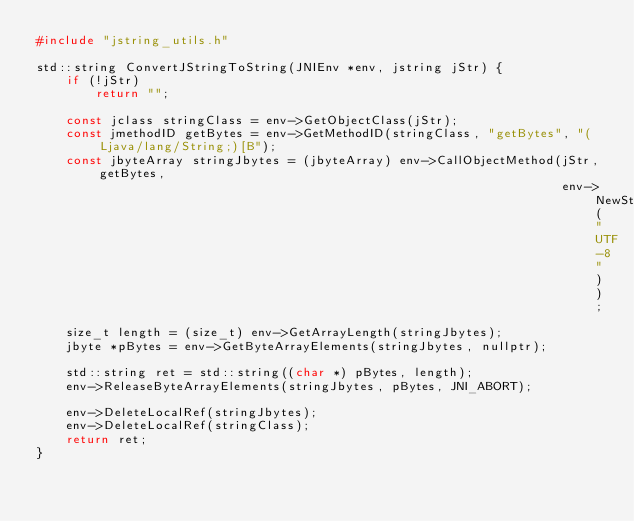<code> <loc_0><loc_0><loc_500><loc_500><_C++_>#include "jstring_utils.h"

std::string ConvertJStringToString(JNIEnv *env, jstring jStr) {
    if (!jStr)
        return "";

    const jclass stringClass = env->GetObjectClass(jStr);
    const jmethodID getBytes = env->GetMethodID(stringClass, "getBytes", "(Ljava/lang/String;)[B");
    const jbyteArray stringJbytes = (jbyteArray) env->CallObjectMethod(jStr, getBytes,
                                                                       env->NewStringUTF("UTF-8"));

    size_t length = (size_t) env->GetArrayLength(stringJbytes);
    jbyte *pBytes = env->GetByteArrayElements(stringJbytes, nullptr);

    std::string ret = std::string((char *) pBytes, length);
    env->ReleaseByteArrayElements(stringJbytes, pBytes, JNI_ABORT);

    env->DeleteLocalRef(stringJbytes);
    env->DeleteLocalRef(stringClass);
    return ret;
}
</code> 